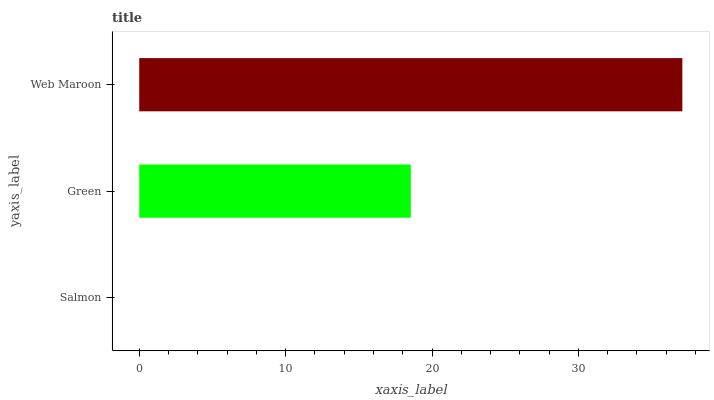Is Salmon the minimum?
Answer yes or no. Yes. Is Web Maroon the maximum?
Answer yes or no. Yes. Is Green the minimum?
Answer yes or no. No. Is Green the maximum?
Answer yes or no. No. Is Green greater than Salmon?
Answer yes or no. Yes. Is Salmon less than Green?
Answer yes or no. Yes. Is Salmon greater than Green?
Answer yes or no. No. Is Green less than Salmon?
Answer yes or no. No. Is Green the high median?
Answer yes or no. Yes. Is Green the low median?
Answer yes or no. Yes. Is Salmon the high median?
Answer yes or no. No. Is Salmon the low median?
Answer yes or no. No. 